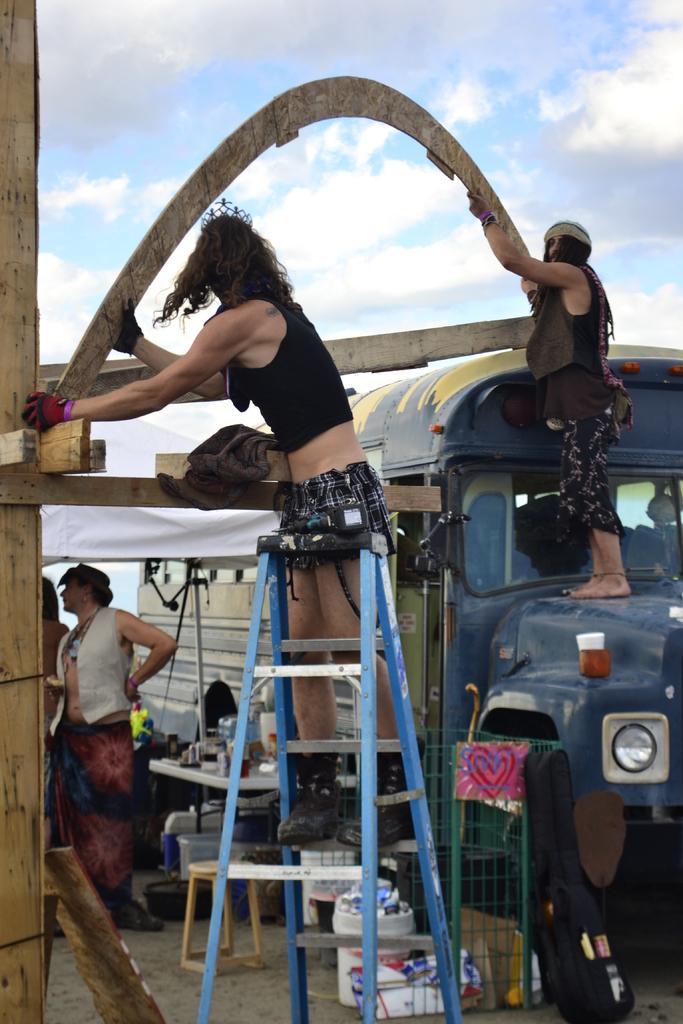Describe this image in one or two sentences. In the picture I can see a person standing on a ladder and holding a wooden object in his hands and there is another person standing on a blue vehicle and holding a wooden object in the right corner and there are two persons and some other objects in the left corner. 